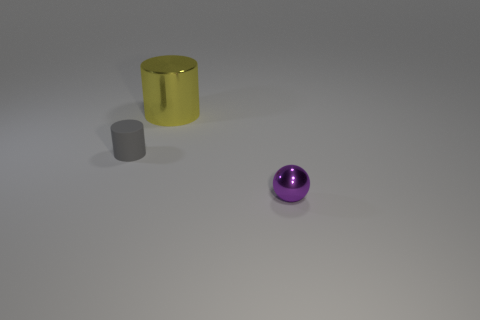The big yellow thing is what shape?
Ensure brevity in your answer.  Cylinder. What number of tiny purple spheres have the same material as the small cylinder?
Ensure brevity in your answer.  0. The other thing that is made of the same material as the small purple object is what color?
Give a very brief answer. Yellow. Do the shiny cylinder and the object that is on the right side of the big cylinder have the same size?
Offer a very short reply. No. The tiny object to the left of the metal object on the right side of the cylinder that is behind the gray cylinder is made of what material?
Provide a succinct answer. Rubber. How many objects are either yellow cylinders or small metallic things?
Offer a very short reply. 2. Does the cylinder in front of the yellow metallic thing have the same color as the metallic ball that is to the right of the large shiny cylinder?
Keep it short and to the point. No. What is the shape of the matte object that is the same size as the shiny ball?
Offer a terse response. Cylinder. How many objects are metal objects behind the rubber cylinder or cylinders that are behind the small rubber cylinder?
Provide a succinct answer. 1. Is the number of big metallic blocks less than the number of tiny purple metal things?
Your response must be concise. Yes. 